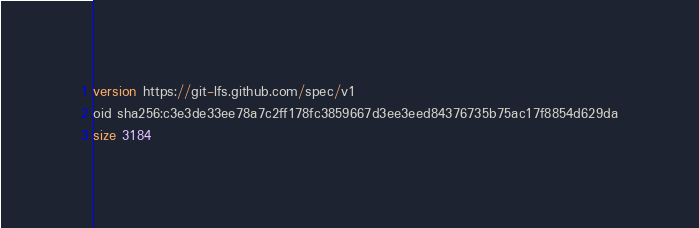<code> <loc_0><loc_0><loc_500><loc_500><_SQL_>version https://git-lfs.github.com/spec/v1
oid sha256:c3e3de33ee78a7c2ff178fc3859667d3ee3eed84376735b75ac17f8854d629da
size 3184
</code> 